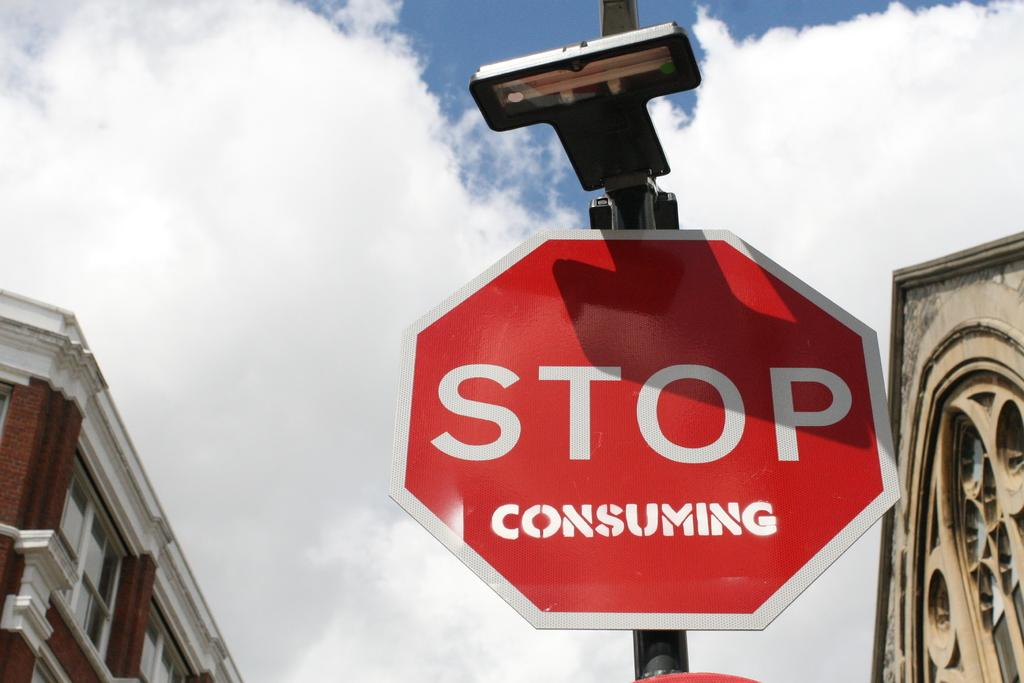<image>
Describe the image concisely. a stop sign that is outside with the word consuming at the bottom 